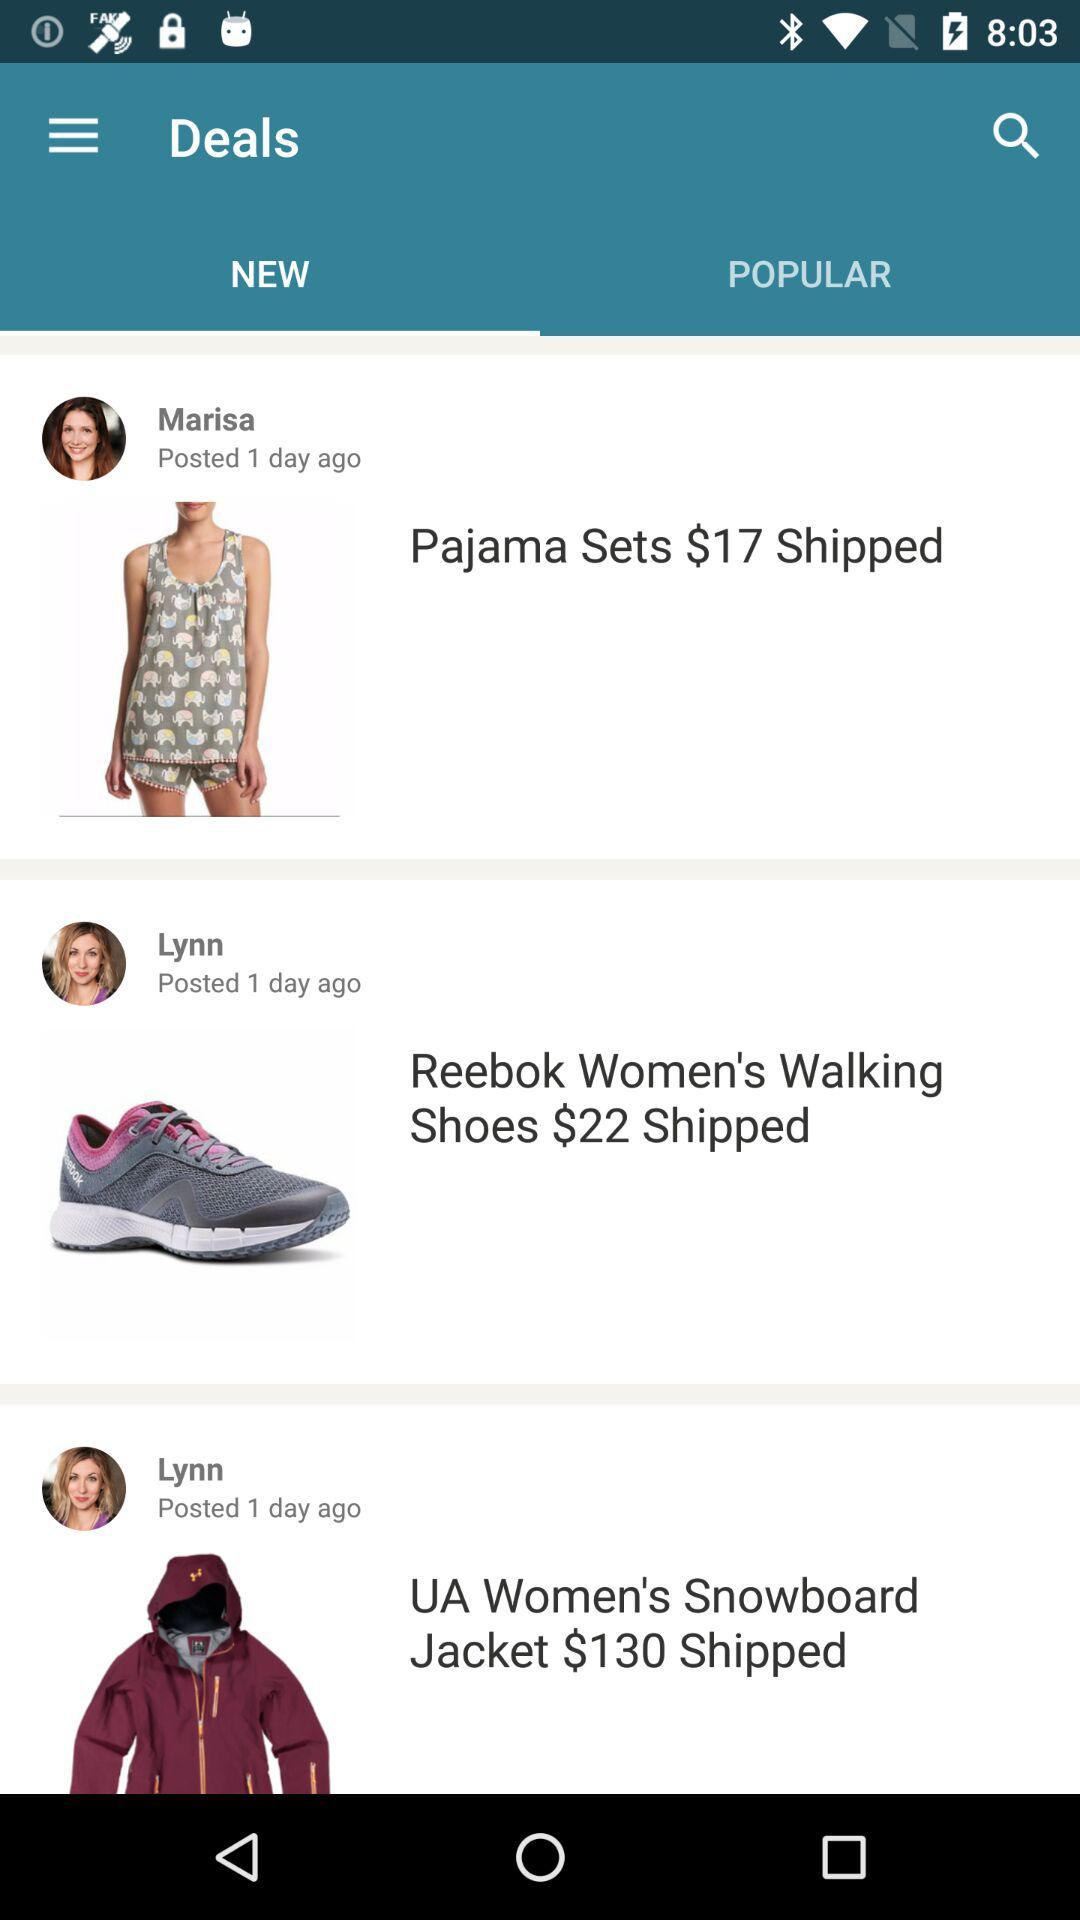Which option is selected in the "Deals"? The selected option is "NEW". 